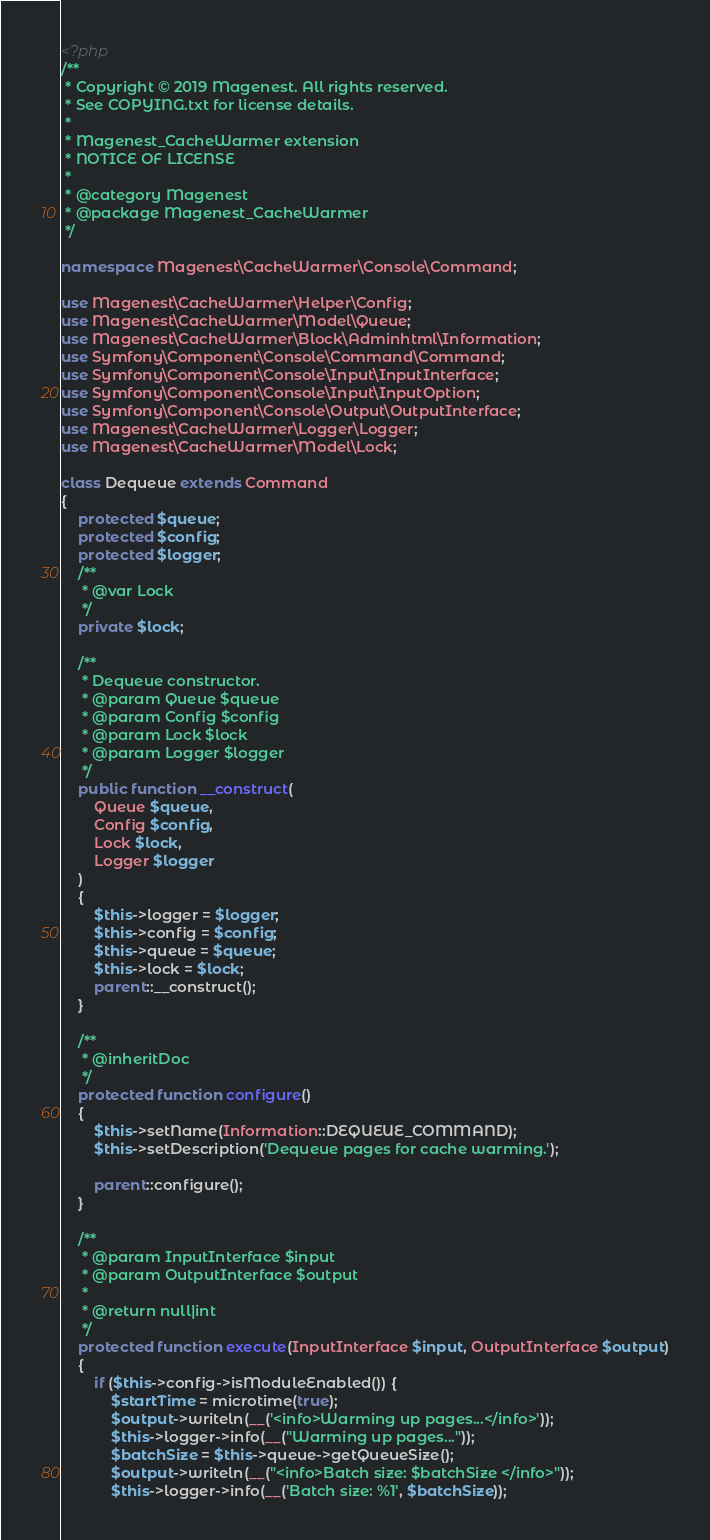Convert code to text. <code><loc_0><loc_0><loc_500><loc_500><_PHP_><?php
/**
 * Copyright © 2019 Magenest. All rights reserved.
 * See COPYING.txt for license details.
 *
 * Magenest_CacheWarmer extension
 * NOTICE OF LICENSE
 *
 * @category Magenest
 * @package Magenest_CacheWarmer
 */

namespace Magenest\CacheWarmer\Console\Command;

use Magenest\CacheWarmer\Helper\Config;
use Magenest\CacheWarmer\Model\Queue;
use Magenest\CacheWarmer\Block\Adminhtml\Information;
use Symfony\Component\Console\Command\Command;
use Symfony\Component\Console\Input\InputInterface;
use Symfony\Component\Console\Input\InputOption;
use Symfony\Component\Console\Output\OutputInterface;
use Magenest\CacheWarmer\Logger\Logger;
use Magenest\CacheWarmer\Model\Lock;

class Dequeue extends Command
{
    protected $queue;
    protected $config;
    protected $logger;
    /**
     * @var Lock
     */
    private $lock;

    /**
     * Dequeue constructor.
     * @param Queue $queue
     * @param Config $config
     * @param Lock $lock
     * @param Logger $logger
     */
    public function __construct(
        Queue $queue,
        Config $config,
        Lock $lock,
        Logger $logger
    )
    {
        $this->logger = $logger;
        $this->config = $config;
        $this->queue = $queue;
        $this->lock = $lock;
        parent::__construct();
    }

    /**
     * @inheritDoc
     */
    protected function configure()
    {
        $this->setName(Information::DEQUEUE_COMMAND);
        $this->setDescription('Dequeue pages for cache warming.');

        parent::configure();
    }

    /**
     * @param InputInterface $input
     * @param OutputInterface $output
     *
     * @return null|int
     */
    protected function execute(InputInterface $input, OutputInterface $output)
    {
        if ($this->config->isModuleEnabled()) {
            $startTime = microtime(true);
            $output->writeln(__('<info>Warming up pages...</info>'));
            $this->logger->info(__("Warming up pages..."));
            $batchSize = $this->queue->getQueueSize();
            $output->writeln(__("<info>Batch size: $batchSize </info>"));
            $this->logger->info(__('Batch size: %1', $batchSize));
</code> 